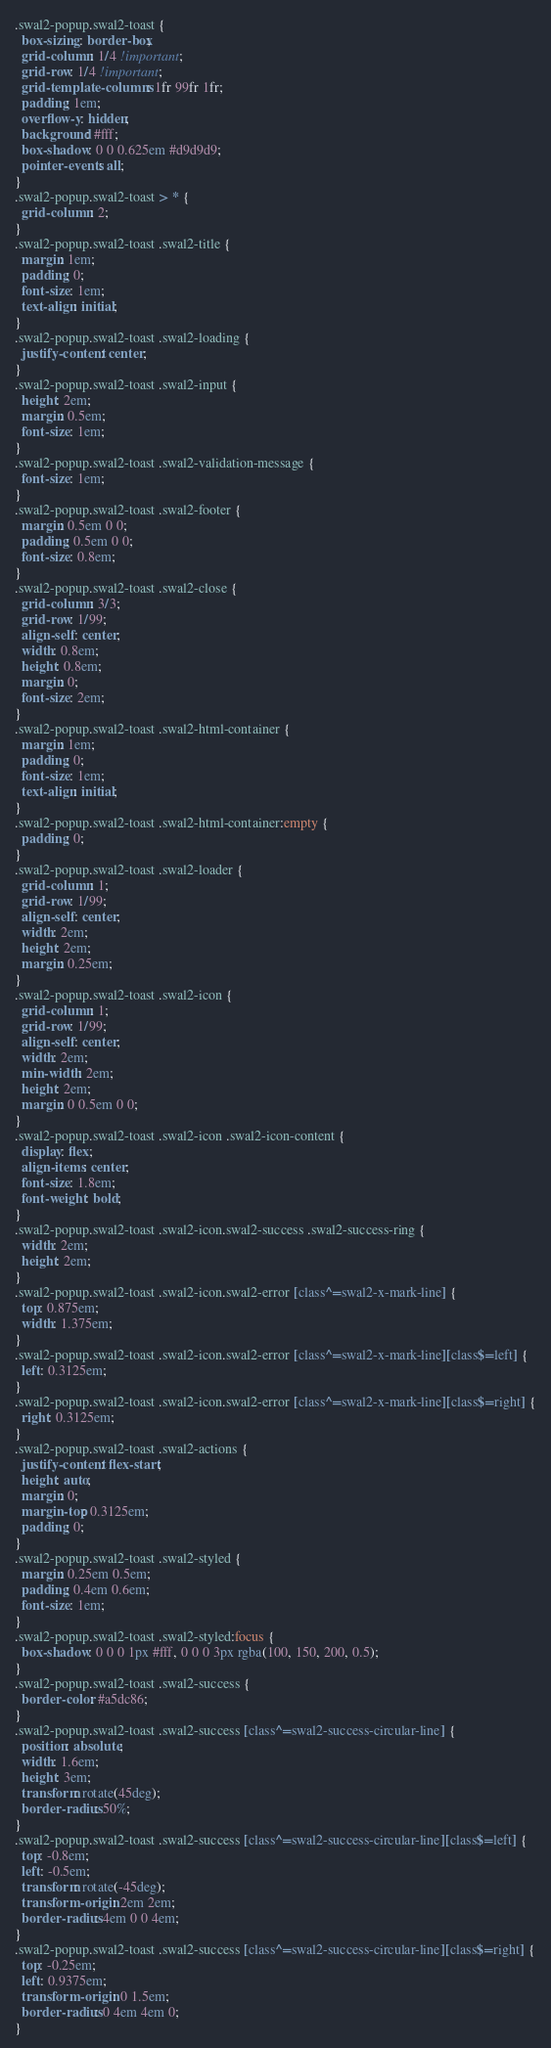Convert code to text. <code><loc_0><loc_0><loc_500><loc_500><_CSS_>.swal2-popup.swal2-toast {
  box-sizing: border-box;
  grid-column: 1/4 !important;
  grid-row: 1/4 !important;
  grid-template-columns: 1fr 99fr 1fr;
  padding: 1em;
  overflow-y: hidden;
  background: #fff;
  box-shadow: 0 0 0.625em #d9d9d9;
  pointer-events: all;
}
.swal2-popup.swal2-toast > * {
  grid-column: 2;
}
.swal2-popup.swal2-toast .swal2-title {
  margin: 1em;
  padding: 0;
  font-size: 1em;
  text-align: initial;
}
.swal2-popup.swal2-toast .swal2-loading {
  justify-content: center;
}
.swal2-popup.swal2-toast .swal2-input {
  height: 2em;
  margin: 0.5em;
  font-size: 1em;
}
.swal2-popup.swal2-toast .swal2-validation-message {
  font-size: 1em;
}
.swal2-popup.swal2-toast .swal2-footer {
  margin: 0.5em 0 0;
  padding: 0.5em 0 0;
  font-size: 0.8em;
}
.swal2-popup.swal2-toast .swal2-close {
  grid-column: 3/3;
  grid-row: 1/99;
  align-self: center;
  width: 0.8em;
  height: 0.8em;
  margin: 0;
  font-size: 2em;
}
.swal2-popup.swal2-toast .swal2-html-container {
  margin: 1em;
  padding: 0;
  font-size: 1em;
  text-align: initial;
}
.swal2-popup.swal2-toast .swal2-html-container:empty {
  padding: 0;
}
.swal2-popup.swal2-toast .swal2-loader {
  grid-column: 1;
  grid-row: 1/99;
  align-self: center;
  width: 2em;
  height: 2em;
  margin: 0.25em;
}
.swal2-popup.swal2-toast .swal2-icon {
  grid-column: 1;
  grid-row: 1/99;
  align-self: center;
  width: 2em;
  min-width: 2em;
  height: 2em;
  margin: 0 0.5em 0 0;
}
.swal2-popup.swal2-toast .swal2-icon .swal2-icon-content {
  display: flex;
  align-items: center;
  font-size: 1.8em;
  font-weight: bold;
}
.swal2-popup.swal2-toast .swal2-icon.swal2-success .swal2-success-ring {
  width: 2em;
  height: 2em;
}
.swal2-popup.swal2-toast .swal2-icon.swal2-error [class^=swal2-x-mark-line] {
  top: 0.875em;
  width: 1.375em;
}
.swal2-popup.swal2-toast .swal2-icon.swal2-error [class^=swal2-x-mark-line][class$=left] {
  left: 0.3125em;
}
.swal2-popup.swal2-toast .swal2-icon.swal2-error [class^=swal2-x-mark-line][class$=right] {
  right: 0.3125em;
}
.swal2-popup.swal2-toast .swal2-actions {
  justify-content: flex-start;
  height: auto;
  margin: 0;
  margin-top: 0.3125em;
  padding: 0;
}
.swal2-popup.swal2-toast .swal2-styled {
  margin: 0.25em 0.5em;
  padding: 0.4em 0.6em;
  font-size: 1em;
}
.swal2-popup.swal2-toast .swal2-styled:focus {
  box-shadow: 0 0 0 1px #fff, 0 0 0 3px rgba(100, 150, 200, 0.5);
}
.swal2-popup.swal2-toast .swal2-success {
  border-color: #a5dc86;
}
.swal2-popup.swal2-toast .swal2-success [class^=swal2-success-circular-line] {
  position: absolute;
  width: 1.6em;
  height: 3em;
  transform: rotate(45deg);
  border-radius: 50%;
}
.swal2-popup.swal2-toast .swal2-success [class^=swal2-success-circular-line][class$=left] {
  top: -0.8em;
  left: -0.5em;
  transform: rotate(-45deg);
  transform-origin: 2em 2em;
  border-radius: 4em 0 0 4em;
}
.swal2-popup.swal2-toast .swal2-success [class^=swal2-success-circular-line][class$=right] {
  top: -0.25em;
  left: 0.9375em;
  transform-origin: 0 1.5em;
  border-radius: 0 4em 4em 0;
}</code> 